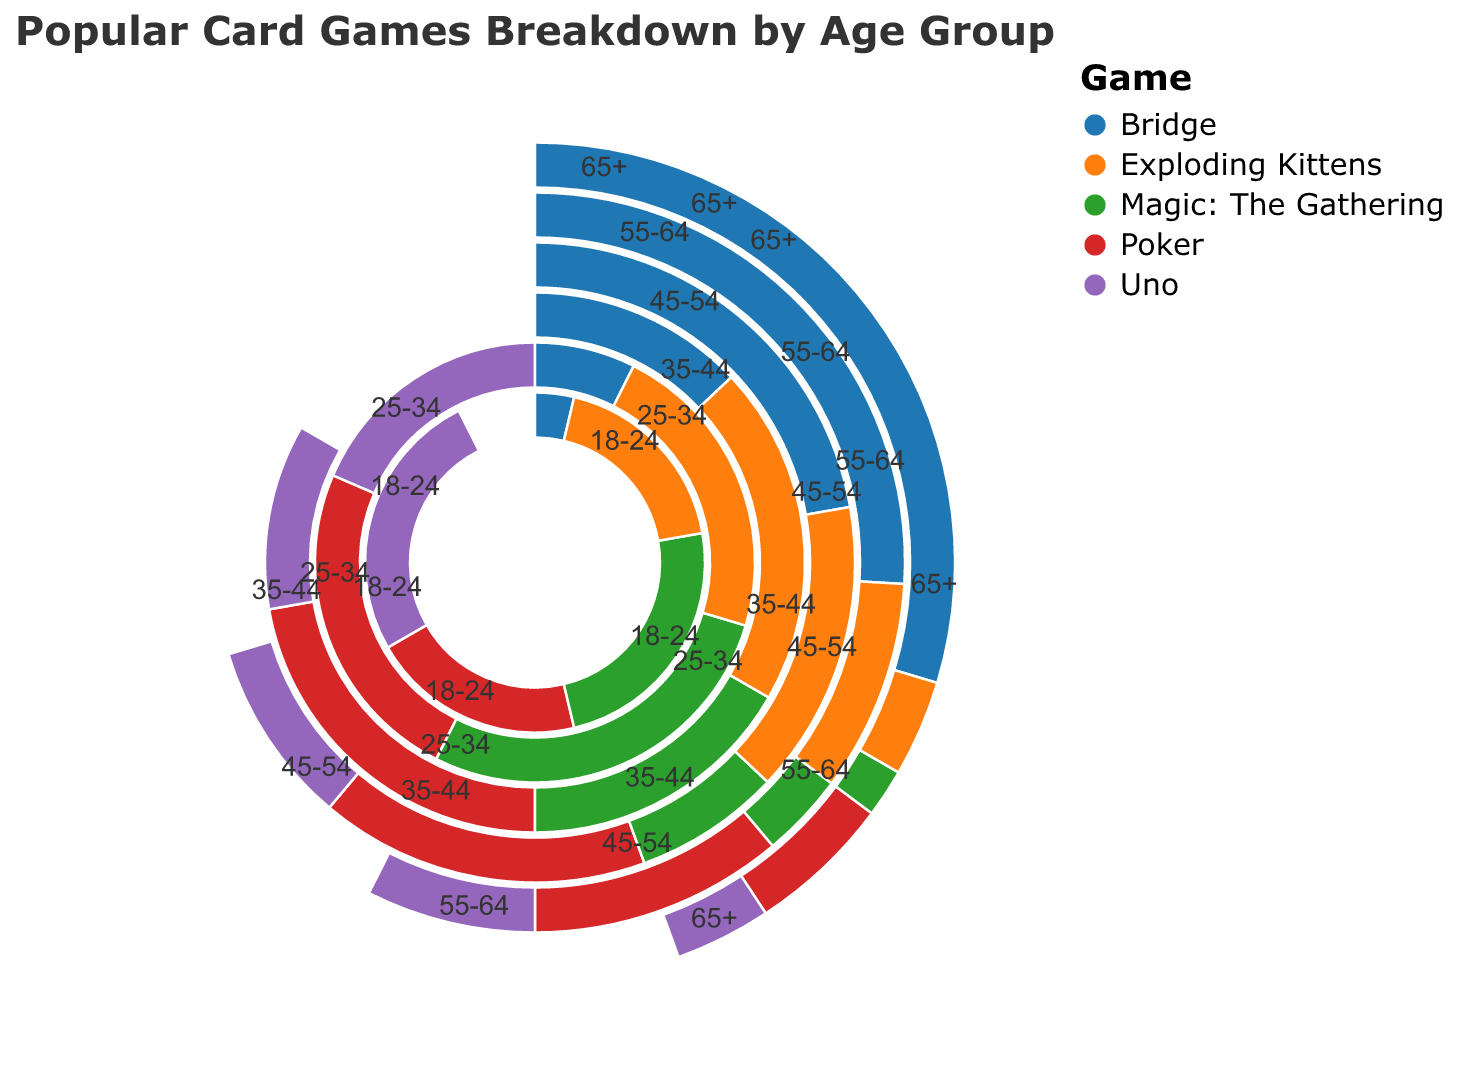What is the title of the chart? The title of the chart is displayed at the top of the figure and reads "Popular Card Games Breakdown by Age Group".
Answer: Popular Card Games Breakdown by Age Group Which age group plays Bridge the most? By looking at the proportion of Bridge for each age group, the 65+ age group has the largest segment, indicating the highest value.
Answer: 65+ How many card games are shown in total in the chart? Count the number of different colors or categories in the legend; there are five: Poker, Uno, Magic: The Gathering, Bridge, and Exploding Kittens.
Answer: 5 What card game is least popular among the 18-24 age group? Compare the lengths of the segments for each game within the 18-24 age group; Bridge has the smallest segment.
Answer: Bridge Which age group has the smallest proportion for Magic: The Gathering? By comparing the sizes of the segments for Magic: The Gathering across all age groups, the 65+ age group has the smallest segment.
Answer: 65+ Which game sees a decline in popularity as age increases? Observe the trends across age groups; Poker has a decreasing trend from 18-24 to 65+.
Answer: Poker In which age group is Uno more popular than Poker? Compare the sizes of the segments for Uno and Poker in each age group; Uno is more popular than Poker in the 18-24 age group.
Answer: 18-24 Between the 35-44 and 45-54 age groups, which one has a higher value for Bridge? Compare the Bridge segment sizes of the 35-44 and 45-54 age groups; the 45-54 age group has a larger segment.
Answer: 45-54 What's the total value for Exploding Kittens in the 18-24 and 25-34 age groups combined? Sum the values for Exploding Kittens in the 18-24 (50) and 25-34 (60) age groups: 50 + 60 = 110.
Answer: 110 Which game has the highest proportion within the 55-64 age group? Within the 55-64 age group, the largest segment is for Bridge.
Answer: Bridge 